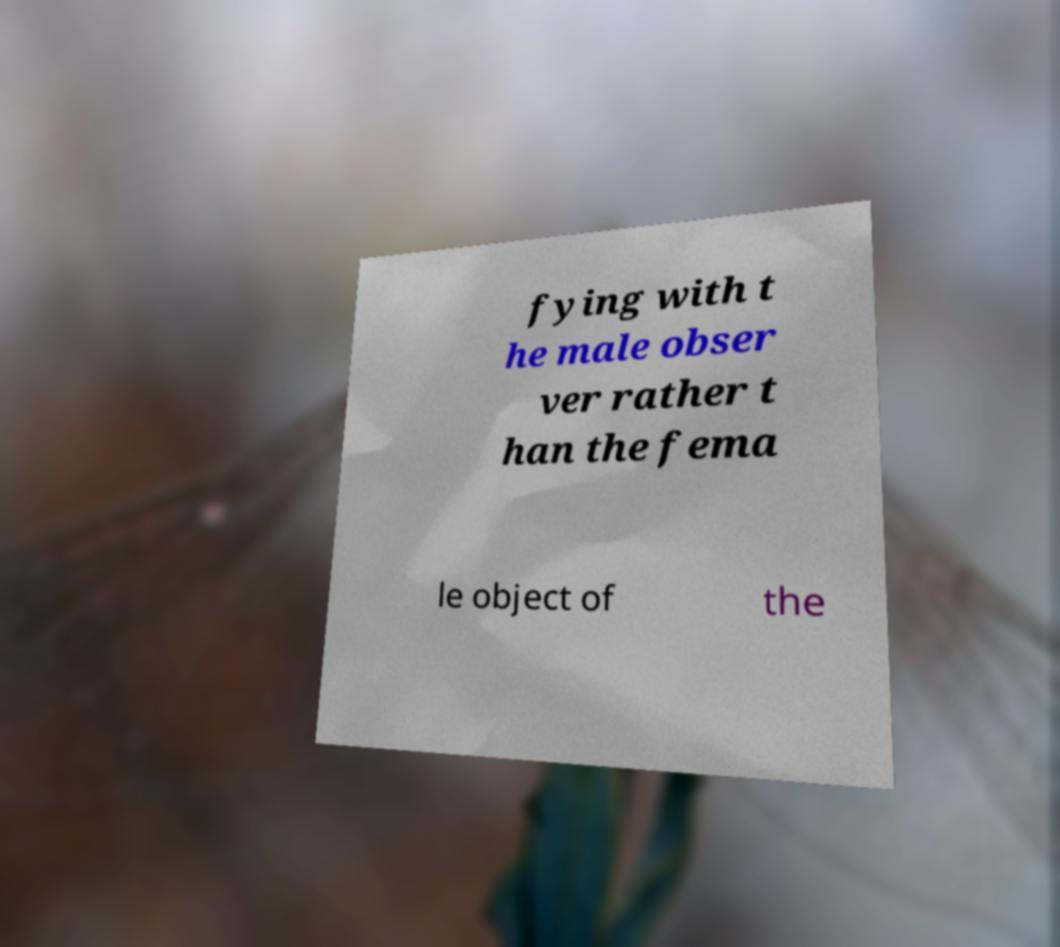Please read and relay the text visible in this image. What does it say? fying with t he male obser ver rather t han the fema le object of the 